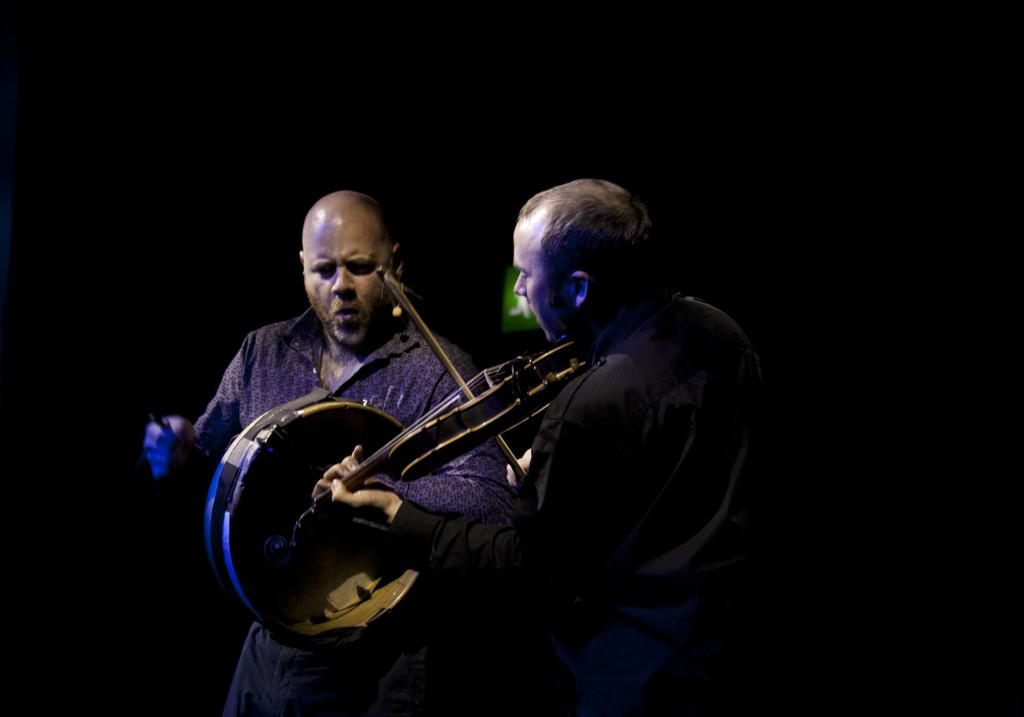How many people are in the image? There are two people in the image. What are the people doing in the image? The people are playing musical instruments. What can be observed about the background of the image? The background of the image is dark. What type of key is being used to play the musical instruments in the image? There is no key present in the image; the people are playing the instruments directly with their hands. 